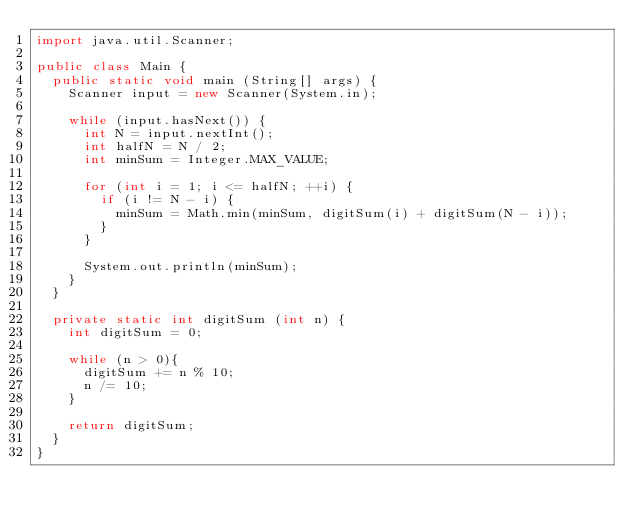<code> <loc_0><loc_0><loc_500><loc_500><_Java_>import java.util.Scanner;

public class Main {
  public static void main (String[] args) {
    Scanner input = new Scanner(System.in);
    
    while (input.hasNext()) {
      int N = input.nextInt();
      int halfN = N / 2;
      int minSum = Integer.MAX_VALUE;
      
      for (int i = 1; i <= halfN; ++i) {
        if (i != N - i) {
          minSum = Math.min(minSum, digitSum(i) + digitSum(N - i));
        }
      }

      System.out.println(minSum);
    }
  }

  private static int digitSum (int n) {
    int digitSum = 0;
    
    while (n > 0){
      digitSum += n % 10;
      n /= 10;
    }
    
    return digitSum;
  }
}</code> 